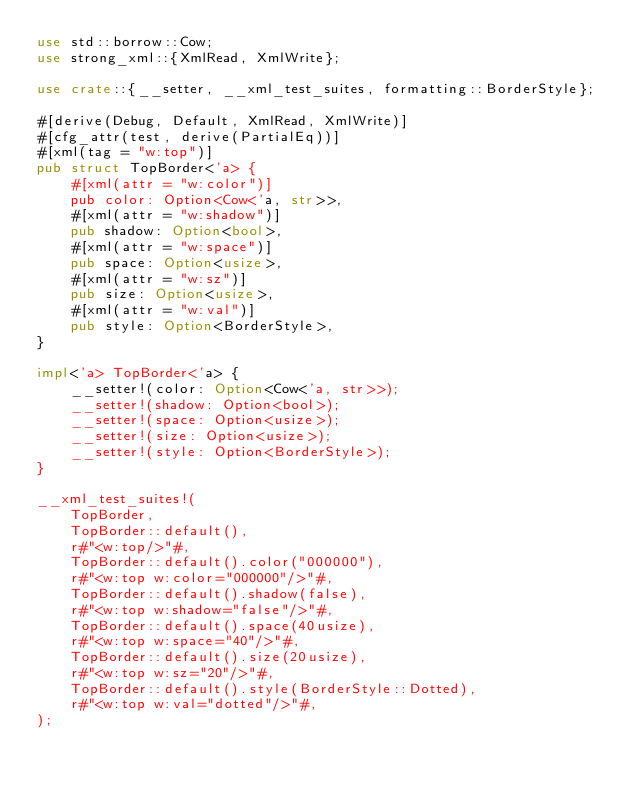<code> <loc_0><loc_0><loc_500><loc_500><_Rust_>use std::borrow::Cow;
use strong_xml::{XmlRead, XmlWrite};

use crate::{__setter, __xml_test_suites, formatting::BorderStyle};

#[derive(Debug, Default, XmlRead, XmlWrite)]
#[cfg_attr(test, derive(PartialEq))]
#[xml(tag = "w:top")]
pub struct TopBorder<'a> {
    #[xml(attr = "w:color")]
    pub color: Option<Cow<'a, str>>,
    #[xml(attr = "w:shadow")]
    pub shadow: Option<bool>,
    #[xml(attr = "w:space")]
    pub space: Option<usize>,
    #[xml(attr = "w:sz")]
    pub size: Option<usize>,
    #[xml(attr = "w:val")]
    pub style: Option<BorderStyle>,
}

impl<'a> TopBorder<'a> {
    __setter!(color: Option<Cow<'a, str>>);
    __setter!(shadow: Option<bool>);
    __setter!(space: Option<usize>);
    __setter!(size: Option<usize>);
    __setter!(style: Option<BorderStyle>);
}

__xml_test_suites!(
    TopBorder,
    TopBorder::default(),
    r#"<w:top/>"#,
    TopBorder::default().color("000000"),
    r#"<w:top w:color="000000"/>"#,
    TopBorder::default().shadow(false),
    r#"<w:top w:shadow="false"/>"#,
    TopBorder::default().space(40usize),
    r#"<w:top w:space="40"/>"#,
    TopBorder::default().size(20usize),
    r#"<w:top w:sz="20"/>"#,
    TopBorder::default().style(BorderStyle::Dotted),
    r#"<w:top w:val="dotted"/>"#,
);
</code> 